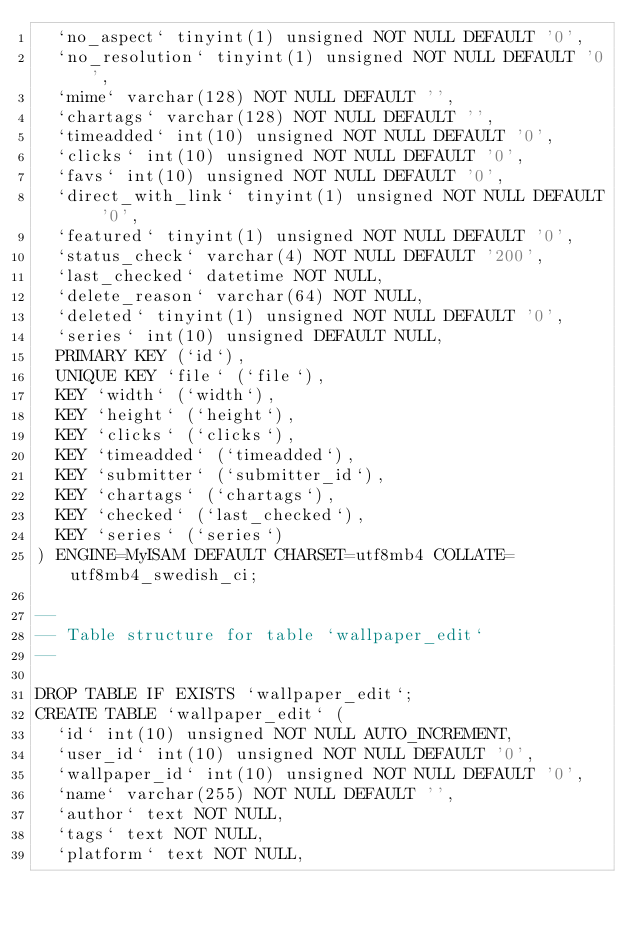<code> <loc_0><loc_0><loc_500><loc_500><_SQL_>  `no_aspect` tinyint(1) unsigned NOT NULL DEFAULT '0',
  `no_resolution` tinyint(1) unsigned NOT NULL DEFAULT '0',
  `mime` varchar(128) NOT NULL DEFAULT '',
  `chartags` varchar(128) NOT NULL DEFAULT '',
  `timeadded` int(10) unsigned NOT NULL DEFAULT '0',
  `clicks` int(10) unsigned NOT NULL DEFAULT '0',
  `favs` int(10) unsigned NOT NULL DEFAULT '0',
  `direct_with_link` tinyint(1) unsigned NOT NULL DEFAULT '0',
  `featured` tinyint(1) unsigned NOT NULL DEFAULT '0',
  `status_check` varchar(4) NOT NULL DEFAULT '200',
  `last_checked` datetime NOT NULL,
  `delete_reason` varchar(64) NOT NULL,
  `deleted` tinyint(1) unsigned NOT NULL DEFAULT '0',
  `series` int(10) unsigned DEFAULT NULL,
  PRIMARY KEY (`id`),
  UNIQUE KEY `file` (`file`),
  KEY `width` (`width`),
  KEY `height` (`height`),
  KEY `clicks` (`clicks`),
  KEY `timeadded` (`timeadded`),
  KEY `submitter` (`submitter_id`),
  KEY `chartags` (`chartags`),
  KEY `checked` (`last_checked`),
  KEY `series` (`series`)
) ENGINE=MyISAM DEFAULT CHARSET=utf8mb4 COLLATE=utf8mb4_swedish_ci;

--
-- Table structure for table `wallpaper_edit`
--

DROP TABLE IF EXISTS `wallpaper_edit`;
CREATE TABLE `wallpaper_edit` (
  `id` int(10) unsigned NOT NULL AUTO_INCREMENT,
  `user_id` int(10) unsigned NOT NULL DEFAULT '0',
  `wallpaper_id` int(10) unsigned NOT NULL DEFAULT '0',
  `name` varchar(255) NOT NULL DEFAULT '',
  `author` text NOT NULL,
  `tags` text NOT NULL,
  `platform` text NOT NULL,</code> 